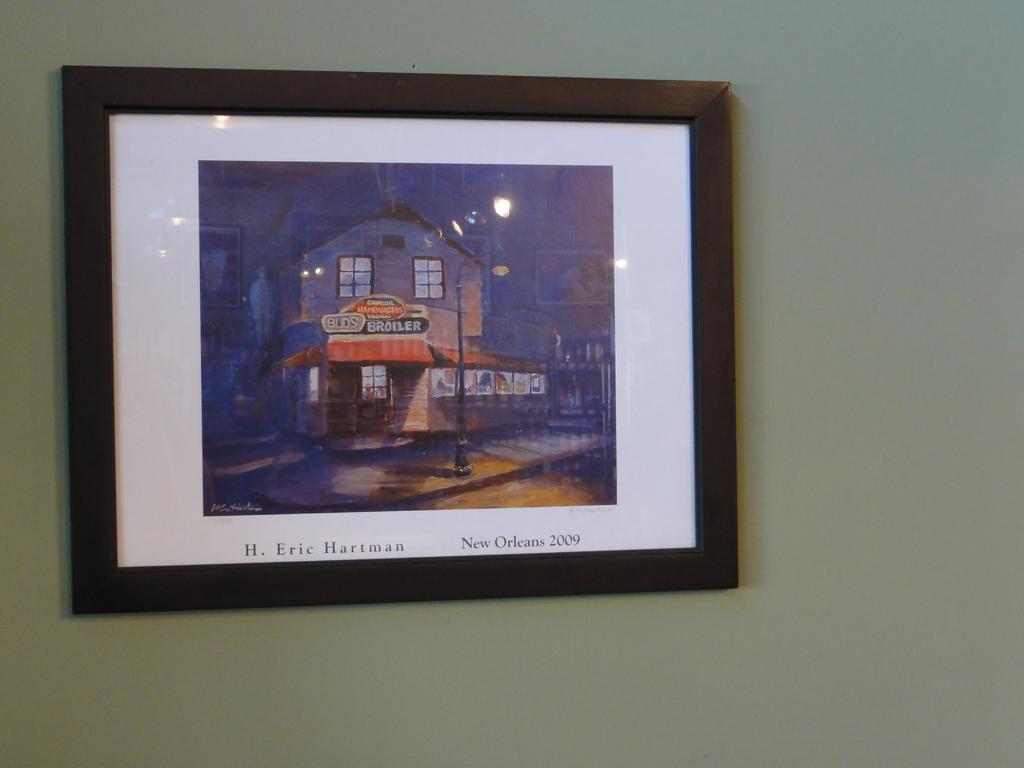<image>
Relay a brief, clear account of the picture shown. a picture that is of New Orleans from 2009 